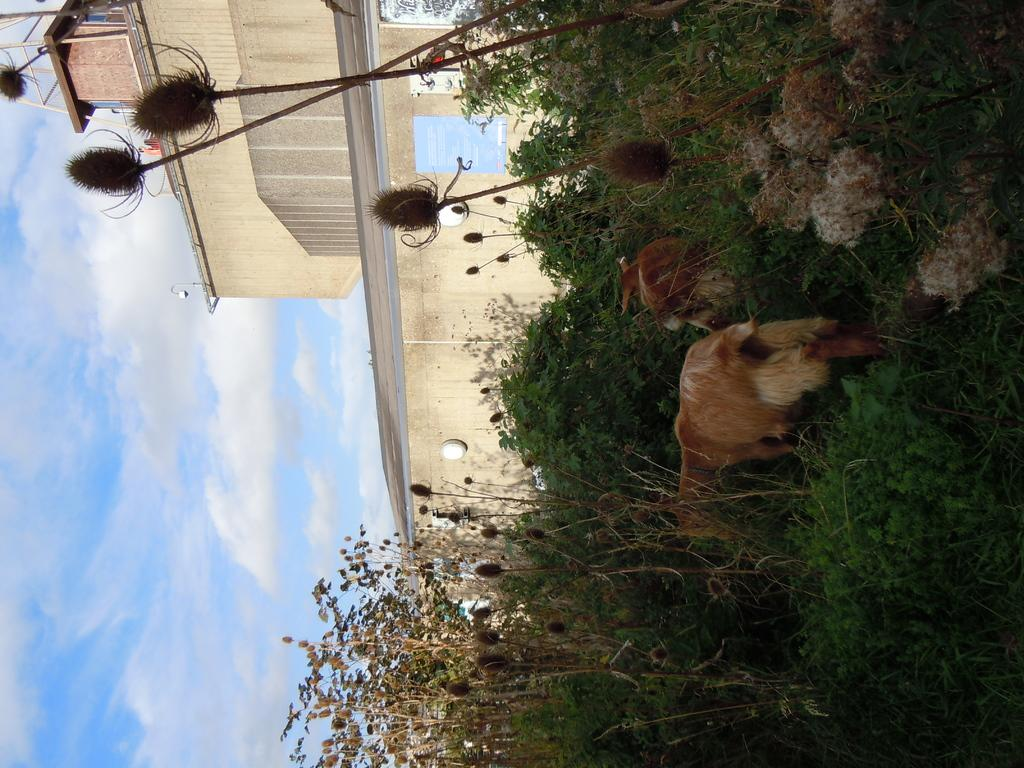What animals are present in the image? There are goats in the image. What color are the goats? The goats are brown in color. What type of vegetation can be seen in the image? There are trees and plants in the image. What type of structure is visible in the image? There is a building in the image. What is the condition of the sky in the image? The sky is blue and cloudy. How many clocks are hanging from the trees in the image? There are no clocks hanging from the trees in the image. What type of wood can be seen in the image? There is no specific type of wood mentioned or visible in the image. 